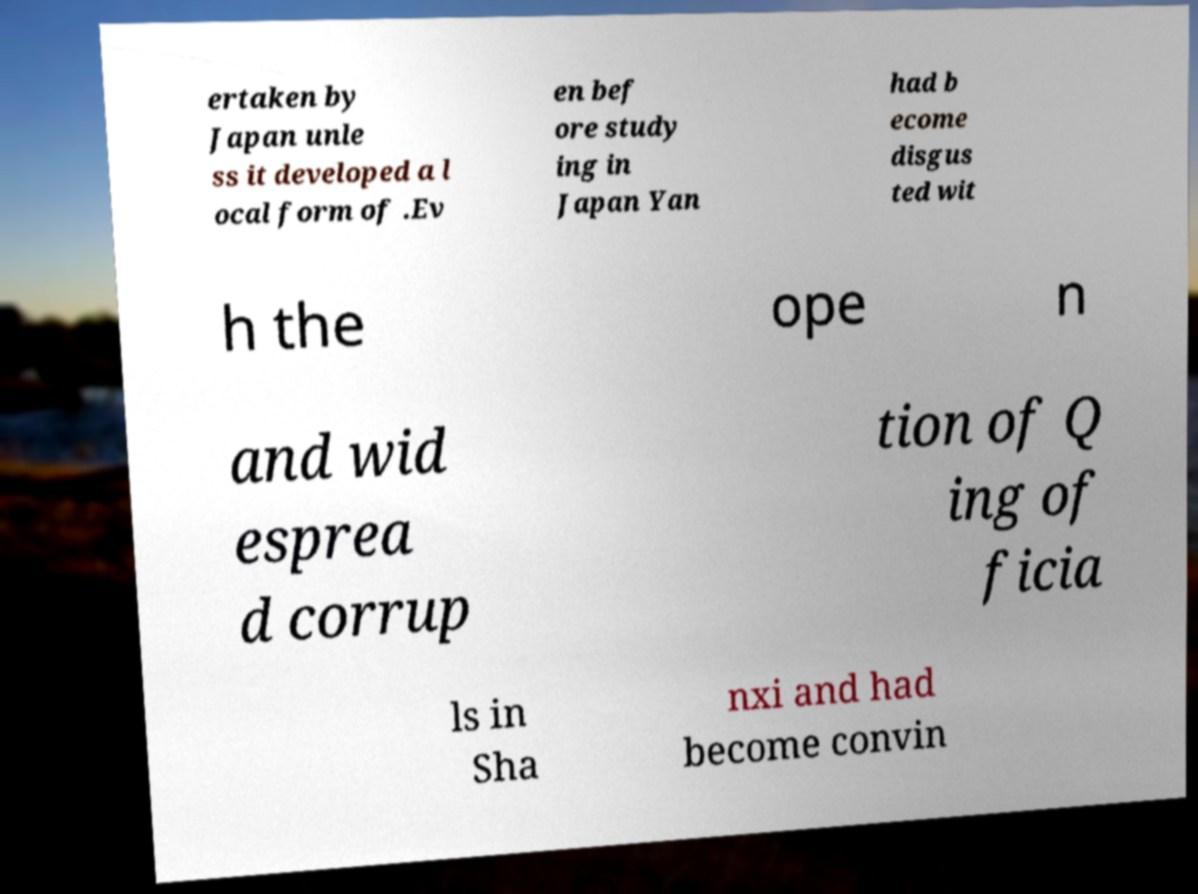Could you extract and type out the text from this image? ertaken by Japan unle ss it developed a l ocal form of .Ev en bef ore study ing in Japan Yan had b ecome disgus ted wit h the ope n and wid esprea d corrup tion of Q ing of ficia ls in Sha nxi and had become convin 